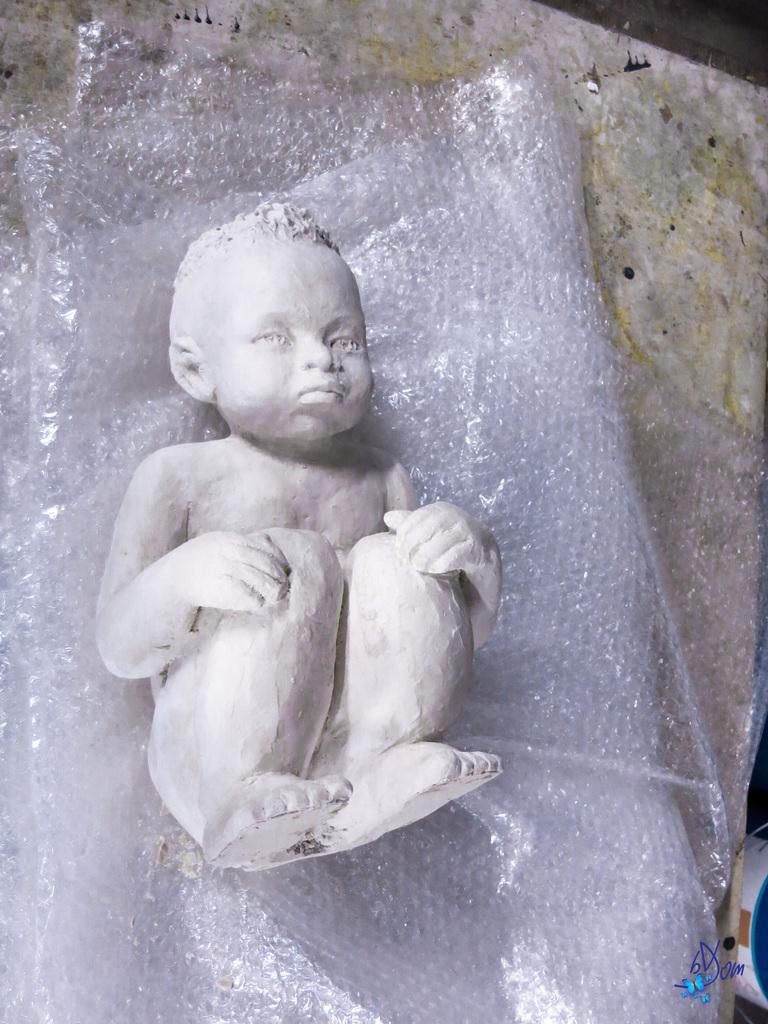Could you give a brief overview of what you see in this image? In this image there is a depiction of a baby placed on the cover, which is on the white color surface, beside that there is an object. 